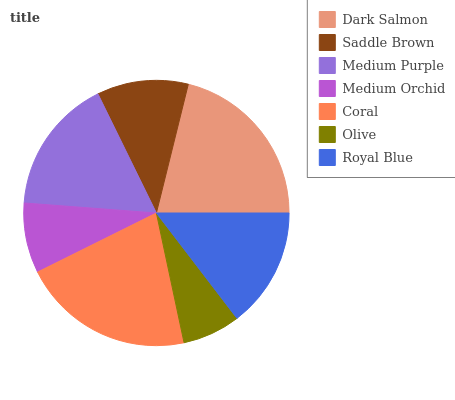Is Olive the minimum?
Answer yes or no. Yes. Is Dark Salmon the maximum?
Answer yes or no. Yes. Is Saddle Brown the minimum?
Answer yes or no. No. Is Saddle Brown the maximum?
Answer yes or no. No. Is Dark Salmon greater than Saddle Brown?
Answer yes or no. Yes. Is Saddle Brown less than Dark Salmon?
Answer yes or no. Yes. Is Saddle Brown greater than Dark Salmon?
Answer yes or no. No. Is Dark Salmon less than Saddle Brown?
Answer yes or no. No. Is Royal Blue the high median?
Answer yes or no. Yes. Is Royal Blue the low median?
Answer yes or no. Yes. Is Saddle Brown the high median?
Answer yes or no. No. Is Coral the low median?
Answer yes or no. No. 